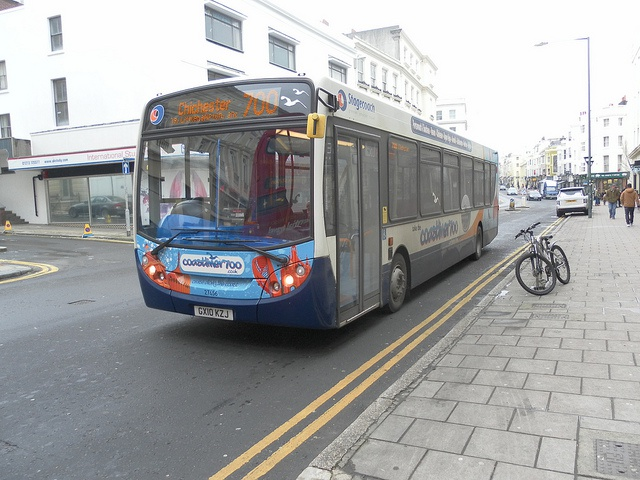Describe the objects in this image and their specific colors. I can see bus in gray, darkgray, lightgray, and black tones, bicycle in gray, darkgray, black, and lightgray tones, car in gray, lightgray, black, and darkgray tones, people in gray, black, and darkgray tones, and people in gray and darkgray tones in this image. 